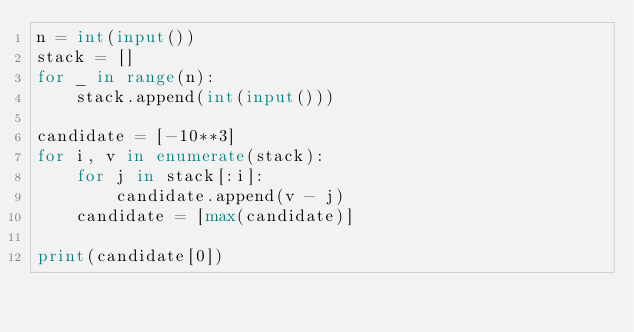Convert code to text. <code><loc_0><loc_0><loc_500><loc_500><_Python_>n = int(input())
stack = []
for _ in range(n):
    stack.append(int(input()))

candidate = [-10**3]
for i, v in enumerate(stack):
    for j in stack[:i]:
        candidate.append(v - j)
    candidate = [max(candidate)]

print(candidate[0])</code> 